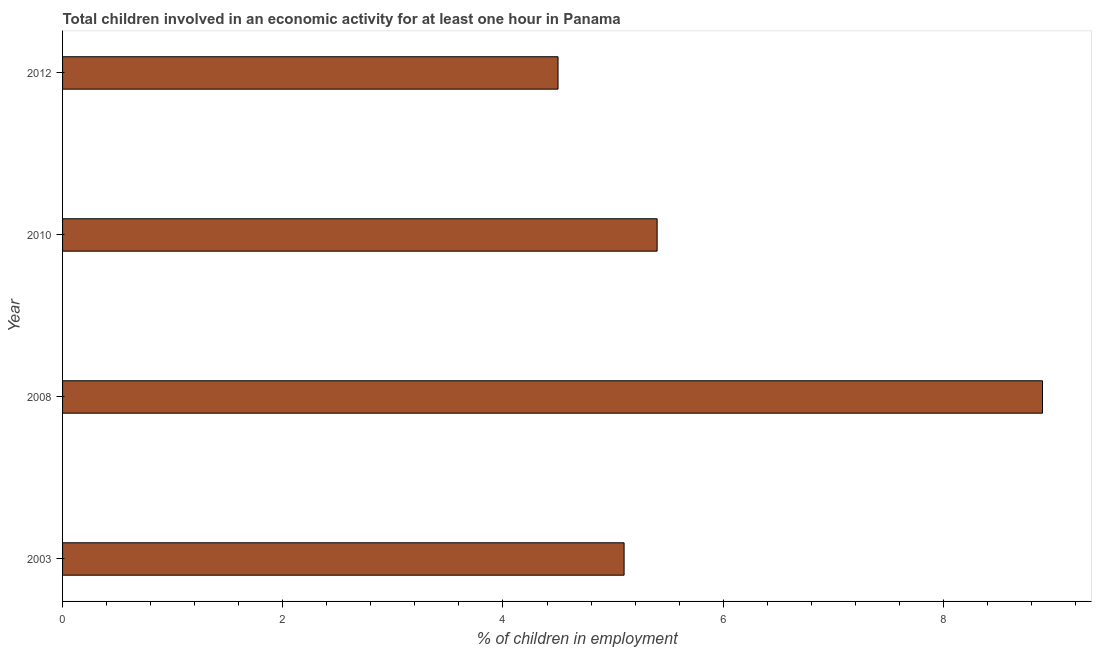Does the graph contain any zero values?
Your answer should be very brief. No. What is the title of the graph?
Offer a very short reply. Total children involved in an economic activity for at least one hour in Panama. What is the label or title of the X-axis?
Provide a succinct answer. % of children in employment. What is the label or title of the Y-axis?
Make the answer very short. Year. Across all years, what is the minimum percentage of children in employment?
Your answer should be compact. 4.5. What is the sum of the percentage of children in employment?
Ensure brevity in your answer.  23.9. What is the average percentage of children in employment per year?
Offer a terse response. 5.97. What is the median percentage of children in employment?
Give a very brief answer. 5.25. In how many years, is the percentage of children in employment greater than 0.8 %?
Offer a terse response. 4. What is the ratio of the percentage of children in employment in 2010 to that in 2012?
Give a very brief answer. 1.2. Is the difference between the percentage of children in employment in 2008 and 2010 greater than the difference between any two years?
Make the answer very short. No. What is the difference between the highest and the second highest percentage of children in employment?
Ensure brevity in your answer.  3.5. Is the sum of the percentage of children in employment in 2008 and 2012 greater than the maximum percentage of children in employment across all years?
Your answer should be compact. Yes. In how many years, is the percentage of children in employment greater than the average percentage of children in employment taken over all years?
Make the answer very short. 1. Are all the bars in the graph horizontal?
Your answer should be compact. Yes. How many years are there in the graph?
Give a very brief answer. 4. What is the % of children in employment of 2008?
Your answer should be very brief. 8.9. What is the % of children in employment in 2010?
Your answer should be very brief. 5.4. What is the % of children in employment in 2012?
Make the answer very short. 4.5. What is the difference between the % of children in employment in 2003 and 2008?
Your answer should be compact. -3.8. What is the difference between the % of children in employment in 2003 and 2012?
Offer a terse response. 0.6. What is the difference between the % of children in employment in 2008 and 2010?
Make the answer very short. 3.5. What is the difference between the % of children in employment in 2008 and 2012?
Provide a short and direct response. 4.4. What is the difference between the % of children in employment in 2010 and 2012?
Your answer should be compact. 0.9. What is the ratio of the % of children in employment in 2003 to that in 2008?
Offer a terse response. 0.57. What is the ratio of the % of children in employment in 2003 to that in 2010?
Provide a succinct answer. 0.94. What is the ratio of the % of children in employment in 2003 to that in 2012?
Your answer should be compact. 1.13. What is the ratio of the % of children in employment in 2008 to that in 2010?
Provide a short and direct response. 1.65. What is the ratio of the % of children in employment in 2008 to that in 2012?
Give a very brief answer. 1.98. 